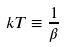<formula> <loc_0><loc_0><loc_500><loc_500>k T \equiv \frac { 1 } { \beta }</formula> 